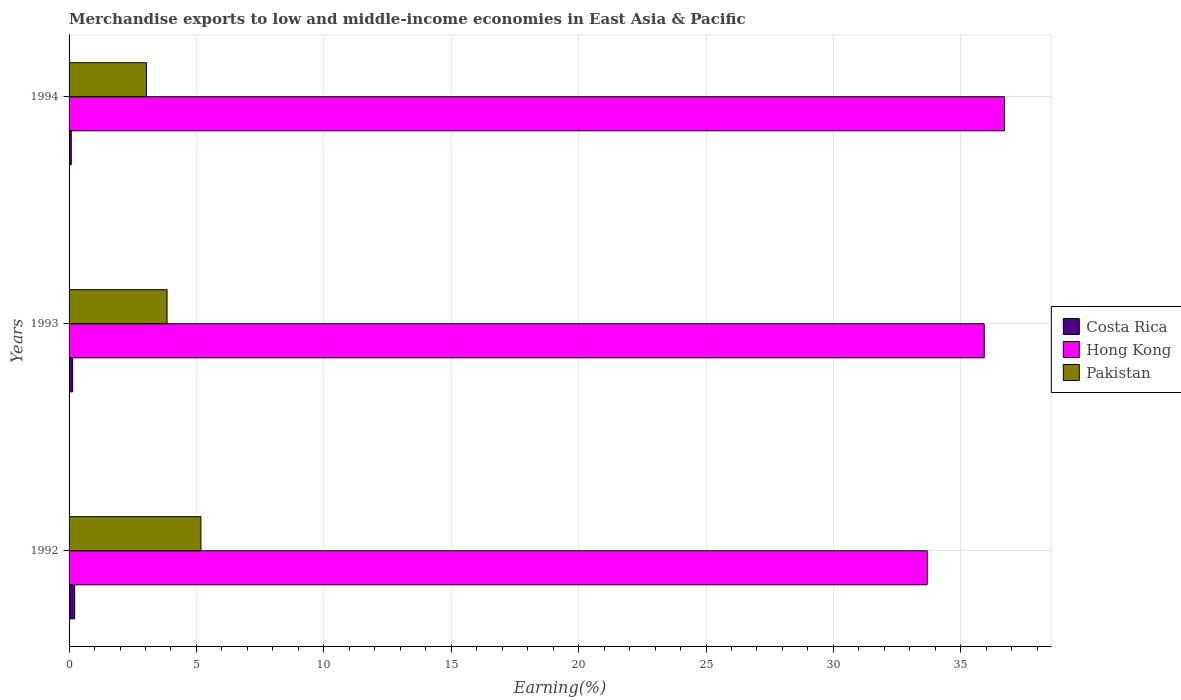How many groups of bars are there?
Your answer should be compact. 3. Are the number of bars per tick equal to the number of legend labels?
Your answer should be very brief. Yes. How many bars are there on the 3rd tick from the top?
Your response must be concise. 3. What is the percentage of amount earned from merchandise exports in Costa Rica in 1993?
Provide a short and direct response. 0.14. Across all years, what is the maximum percentage of amount earned from merchandise exports in Pakistan?
Your response must be concise. 5.18. Across all years, what is the minimum percentage of amount earned from merchandise exports in Costa Rica?
Offer a terse response. 0.09. In which year was the percentage of amount earned from merchandise exports in Pakistan maximum?
Keep it short and to the point. 1992. In which year was the percentage of amount earned from merchandise exports in Costa Rica minimum?
Make the answer very short. 1994. What is the total percentage of amount earned from merchandise exports in Pakistan in the graph?
Offer a very short reply. 12.06. What is the difference between the percentage of amount earned from merchandise exports in Costa Rica in 1993 and that in 1994?
Provide a succinct answer. 0.05. What is the difference between the percentage of amount earned from merchandise exports in Pakistan in 1993 and the percentage of amount earned from merchandise exports in Costa Rica in 1994?
Offer a very short reply. 3.76. What is the average percentage of amount earned from merchandise exports in Pakistan per year?
Your answer should be compact. 4.02. In the year 1993, what is the difference between the percentage of amount earned from merchandise exports in Hong Kong and percentage of amount earned from merchandise exports in Costa Rica?
Make the answer very short. 35.78. In how many years, is the percentage of amount earned from merchandise exports in Hong Kong greater than 12 %?
Ensure brevity in your answer.  3. What is the ratio of the percentage of amount earned from merchandise exports in Costa Rica in 1992 to that in 1994?
Ensure brevity in your answer.  2.55. Is the percentage of amount earned from merchandise exports in Pakistan in 1992 less than that in 1994?
Ensure brevity in your answer.  No. Is the difference between the percentage of amount earned from merchandise exports in Hong Kong in 1993 and 1994 greater than the difference between the percentage of amount earned from merchandise exports in Costa Rica in 1993 and 1994?
Keep it short and to the point. No. What is the difference between the highest and the second highest percentage of amount earned from merchandise exports in Pakistan?
Your answer should be compact. 1.33. What is the difference between the highest and the lowest percentage of amount earned from merchandise exports in Pakistan?
Make the answer very short. 2.14. In how many years, is the percentage of amount earned from merchandise exports in Pakistan greater than the average percentage of amount earned from merchandise exports in Pakistan taken over all years?
Give a very brief answer. 1. What does the 2nd bar from the top in 1994 represents?
Give a very brief answer. Hong Kong. What does the 2nd bar from the bottom in 1994 represents?
Ensure brevity in your answer.  Hong Kong. Is it the case that in every year, the sum of the percentage of amount earned from merchandise exports in Hong Kong and percentage of amount earned from merchandise exports in Pakistan is greater than the percentage of amount earned from merchandise exports in Costa Rica?
Offer a terse response. Yes. How many bars are there?
Your response must be concise. 9. How many years are there in the graph?
Ensure brevity in your answer.  3. Does the graph contain any zero values?
Keep it short and to the point. No. Does the graph contain grids?
Give a very brief answer. Yes. Where does the legend appear in the graph?
Keep it short and to the point. Center right. What is the title of the graph?
Offer a terse response. Merchandise exports to low and middle-income economies in East Asia & Pacific. Does "Indonesia" appear as one of the legend labels in the graph?
Provide a succinct answer. No. What is the label or title of the X-axis?
Your answer should be compact. Earning(%). What is the Earning(%) of Costa Rica in 1992?
Give a very brief answer. 0.22. What is the Earning(%) of Hong Kong in 1992?
Your answer should be compact. 33.68. What is the Earning(%) in Pakistan in 1992?
Your answer should be very brief. 5.18. What is the Earning(%) in Costa Rica in 1993?
Your answer should be compact. 0.14. What is the Earning(%) of Hong Kong in 1993?
Make the answer very short. 35.92. What is the Earning(%) in Pakistan in 1993?
Make the answer very short. 3.85. What is the Earning(%) in Costa Rica in 1994?
Your response must be concise. 0.09. What is the Earning(%) in Hong Kong in 1994?
Give a very brief answer. 36.72. What is the Earning(%) of Pakistan in 1994?
Your response must be concise. 3.04. Across all years, what is the maximum Earning(%) in Costa Rica?
Keep it short and to the point. 0.22. Across all years, what is the maximum Earning(%) of Hong Kong?
Keep it short and to the point. 36.72. Across all years, what is the maximum Earning(%) of Pakistan?
Keep it short and to the point. 5.18. Across all years, what is the minimum Earning(%) in Costa Rica?
Provide a short and direct response. 0.09. Across all years, what is the minimum Earning(%) of Hong Kong?
Your answer should be compact. 33.68. Across all years, what is the minimum Earning(%) of Pakistan?
Ensure brevity in your answer.  3.04. What is the total Earning(%) of Costa Rica in the graph?
Ensure brevity in your answer.  0.45. What is the total Earning(%) in Hong Kong in the graph?
Keep it short and to the point. 106.32. What is the total Earning(%) in Pakistan in the graph?
Your response must be concise. 12.06. What is the difference between the Earning(%) in Costa Rica in 1992 and that in 1993?
Your answer should be very brief. 0.08. What is the difference between the Earning(%) in Hong Kong in 1992 and that in 1993?
Your answer should be very brief. -2.24. What is the difference between the Earning(%) of Pakistan in 1992 and that in 1993?
Offer a very short reply. 1.33. What is the difference between the Earning(%) of Costa Rica in 1992 and that in 1994?
Give a very brief answer. 0.13. What is the difference between the Earning(%) in Hong Kong in 1992 and that in 1994?
Your answer should be very brief. -3.04. What is the difference between the Earning(%) in Pakistan in 1992 and that in 1994?
Provide a short and direct response. 2.14. What is the difference between the Earning(%) in Costa Rica in 1993 and that in 1994?
Make the answer very short. 0.05. What is the difference between the Earning(%) in Hong Kong in 1993 and that in 1994?
Your response must be concise. -0.8. What is the difference between the Earning(%) of Pakistan in 1993 and that in 1994?
Make the answer very short. 0.81. What is the difference between the Earning(%) of Costa Rica in 1992 and the Earning(%) of Hong Kong in 1993?
Your response must be concise. -35.7. What is the difference between the Earning(%) of Costa Rica in 1992 and the Earning(%) of Pakistan in 1993?
Offer a terse response. -3.63. What is the difference between the Earning(%) of Hong Kong in 1992 and the Earning(%) of Pakistan in 1993?
Ensure brevity in your answer.  29.84. What is the difference between the Earning(%) in Costa Rica in 1992 and the Earning(%) in Hong Kong in 1994?
Your answer should be compact. -36.5. What is the difference between the Earning(%) of Costa Rica in 1992 and the Earning(%) of Pakistan in 1994?
Offer a terse response. -2.82. What is the difference between the Earning(%) of Hong Kong in 1992 and the Earning(%) of Pakistan in 1994?
Make the answer very short. 30.65. What is the difference between the Earning(%) of Costa Rica in 1993 and the Earning(%) of Hong Kong in 1994?
Ensure brevity in your answer.  -36.58. What is the difference between the Earning(%) in Costa Rica in 1993 and the Earning(%) in Pakistan in 1994?
Your answer should be very brief. -2.89. What is the difference between the Earning(%) of Hong Kong in 1993 and the Earning(%) of Pakistan in 1994?
Offer a terse response. 32.88. What is the average Earning(%) in Costa Rica per year?
Offer a terse response. 0.15. What is the average Earning(%) in Hong Kong per year?
Provide a short and direct response. 35.44. What is the average Earning(%) of Pakistan per year?
Provide a short and direct response. 4.02. In the year 1992, what is the difference between the Earning(%) of Costa Rica and Earning(%) of Hong Kong?
Your response must be concise. -33.46. In the year 1992, what is the difference between the Earning(%) in Costa Rica and Earning(%) in Pakistan?
Make the answer very short. -4.96. In the year 1992, what is the difference between the Earning(%) of Hong Kong and Earning(%) of Pakistan?
Offer a very short reply. 28.5. In the year 1993, what is the difference between the Earning(%) of Costa Rica and Earning(%) of Hong Kong?
Offer a terse response. -35.78. In the year 1993, what is the difference between the Earning(%) of Costa Rica and Earning(%) of Pakistan?
Provide a succinct answer. -3.71. In the year 1993, what is the difference between the Earning(%) in Hong Kong and Earning(%) in Pakistan?
Ensure brevity in your answer.  32.07. In the year 1994, what is the difference between the Earning(%) of Costa Rica and Earning(%) of Hong Kong?
Ensure brevity in your answer.  -36.63. In the year 1994, what is the difference between the Earning(%) of Costa Rica and Earning(%) of Pakistan?
Keep it short and to the point. -2.95. In the year 1994, what is the difference between the Earning(%) in Hong Kong and Earning(%) in Pakistan?
Offer a very short reply. 33.68. What is the ratio of the Earning(%) in Costa Rica in 1992 to that in 1993?
Make the answer very short. 1.56. What is the ratio of the Earning(%) in Hong Kong in 1992 to that in 1993?
Offer a terse response. 0.94. What is the ratio of the Earning(%) in Pakistan in 1992 to that in 1993?
Offer a terse response. 1.35. What is the ratio of the Earning(%) in Costa Rica in 1992 to that in 1994?
Your response must be concise. 2.55. What is the ratio of the Earning(%) of Hong Kong in 1992 to that in 1994?
Provide a short and direct response. 0.92. What is the ratio of the Earning(%) in Pakistan in 1992 to that in 1994?
Your answer should be compact. 1.71. What is the ratio of the Earning(%) of Costa Rica in 1993 to that in 1994?
Your answer should be compact. 1.63. What is the ratio of the Earning(%) of Hong Kong in 1993 to that in 1994?
Your answer should be very brief. 0.98. What is the ratio of the Earning(%) in Pakistan in 1993 to that in 1994?
Your answer should be compact. 1.27. What is the difference between the highest and the second highest Earning(%) in Costa Rica?
Offer a terse response. 0.08. What is the difference between the highest and the second highest Earning(%) in Hong Kong?
Make the answer very short. 0.8. What is the difference between the highest and the second highest Earning(%) in Pakistan?
Offer a terse response. 1.33. What is the difference between the highest and the lowest Earning(%) in Costa Rica?
Ensure brevity in your answer.  0.13. What is the difference between the highest and the lowest Earning(%) in Hong Kong?
Your response must be concise. 3.04. What is the difference between the highest and the lowest Earning(%) in Pakistan?
Offer a terse response. 2.14. 